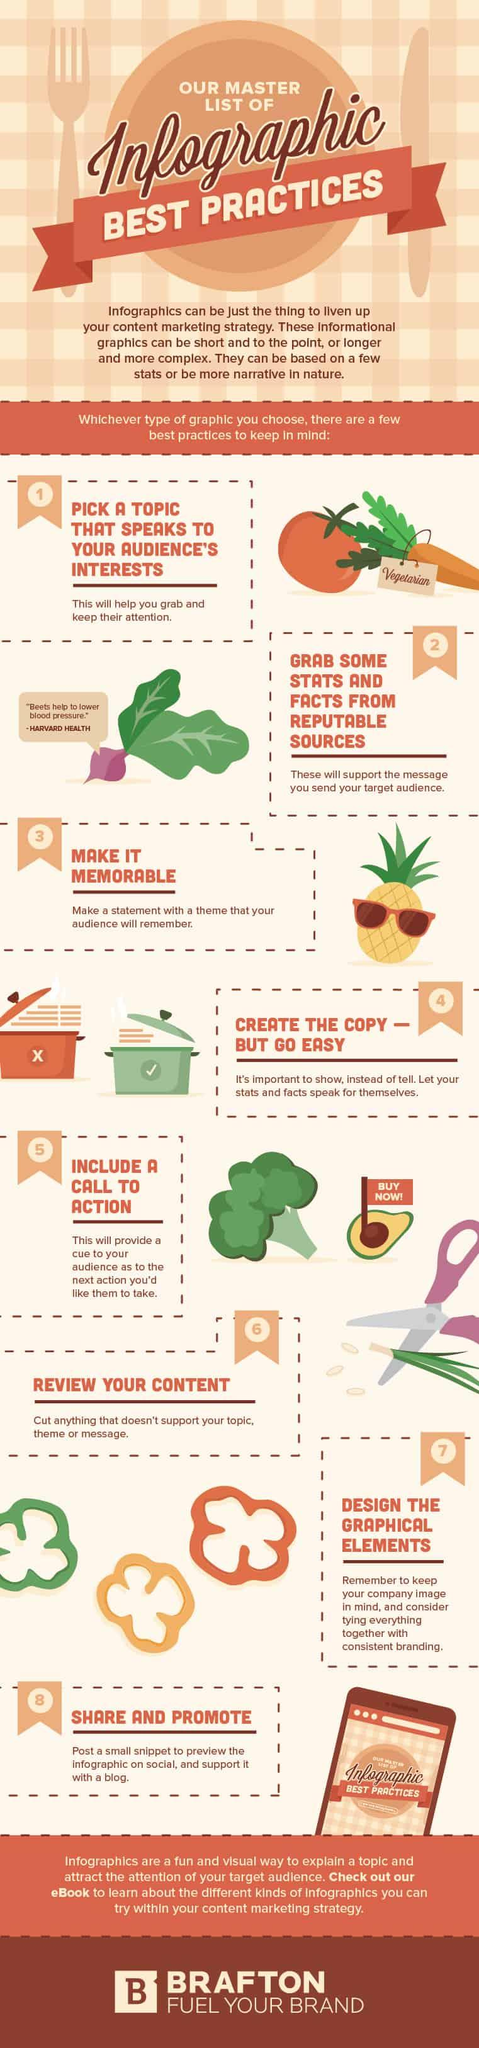Draw attention to some important aspects in this diagram. Beetroots are the vegetable that has been shown to help reduce blood pressure. Avocado is placed on the fruit that displays a red flag. 